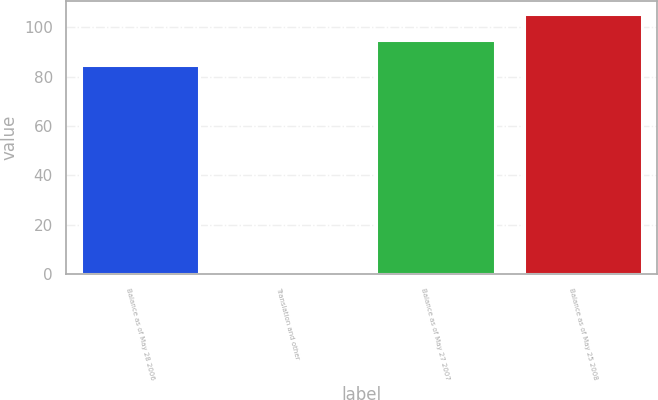Convert chart. <chart><loc_0><loc_0><loc_500><loc_500><bar_chart><fcel>Balance as of May 28 2006<fcel>Translation and other<fcel>Balance as of May 27 2007<fcel>Balance as of May 25 2008<nl><fcel>84.8<fcel>0.6<fcel>95.02<fcel>105.24<nl></chart> 